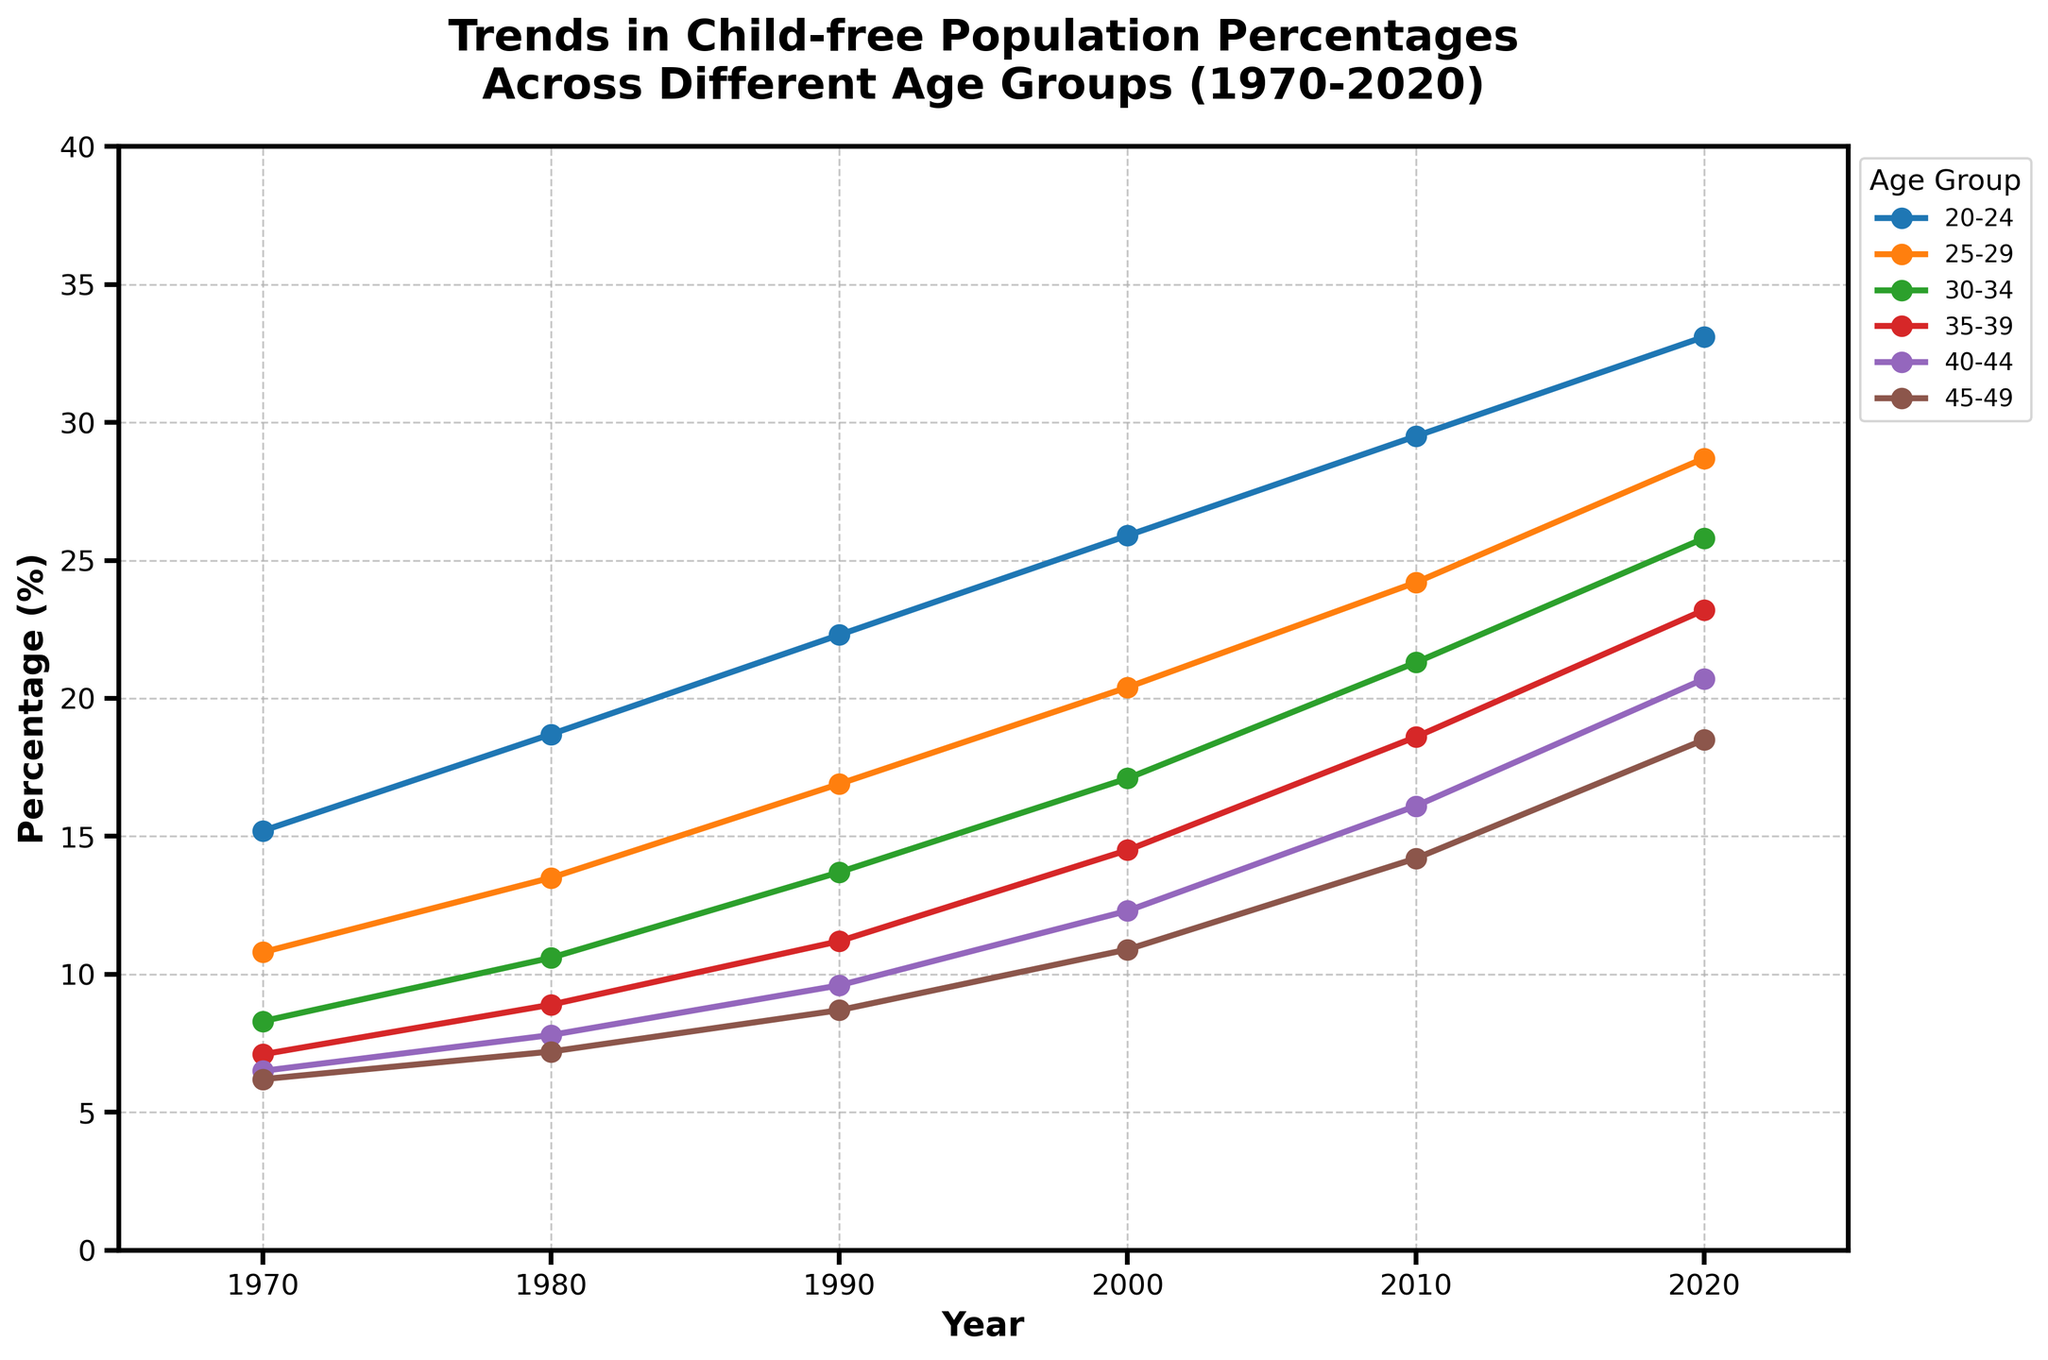What is the percentage of the 30-34 age group in 2020? Look for the data point for the 30-34 age group in the year 2020 on the plot.
Answer: 25.8 Which age group had the highest percentage of child-free individuals in 1980? Compare the 1980 data points across all age groups. The highest percentage is 18.7% for the 20-24 age group.
Answer: 20-24 Did the 25-29 age group's child-free percentage increase or decrease from 1990 to 2000? Observe the 25-29 age group line from 1990 to 2000. The percentage went from 16.9% in 1990 to 20.4% in 2000, showing an increase.
Answer: Increase What is the difference in the percentage of child-free individuals between the 20-24 and 45-49 age groups in 2020? Subtract the percentage of the 45-49 age group in 2020 (18.5%) from the percentage of the 20-24 age group in 2020 (33.1%).
Answer: 14.6 Which age group has shown the least increase in the percentage of child-free individuals from 1970 to 2020? Calculate the percentage increase for each age group by subtracting the 1970 percentage from the 2020 percentage for each group and compare. The least increase is for the 45-49 age group (18.5% - 6.2% = 12.3%).
Answer: 45-49 What is the average percentage of child-free individuals for the 35-39 age group across all years shown? Add the percentages for the 35-39 age group across all years and divide by the number of data points (7.1, 8.9, 11.2, 14.5, 18.6, 23.2). (7.1 + 8.9 + 11.2 + 14.5 + 18.6 + 23.2) / 6 = 13.92
Answer: 13.92 Does any age group have a year where it surpasses the child-free percentage of the 45-49 age group in 2020 (18.5%)? Observe the plot for each age group; all age groups in 2020 surpass 18.5%, except the 45-49 age group.
Answer: Yes Which two age groups have the closest percentage of child-free individuals in 2000? Compare the 2000 data points for all age groups. The 40-44 (12.3%) and 35-39 (14.5%) age groups are the closest.
Answer: 40-44 and 35-39 